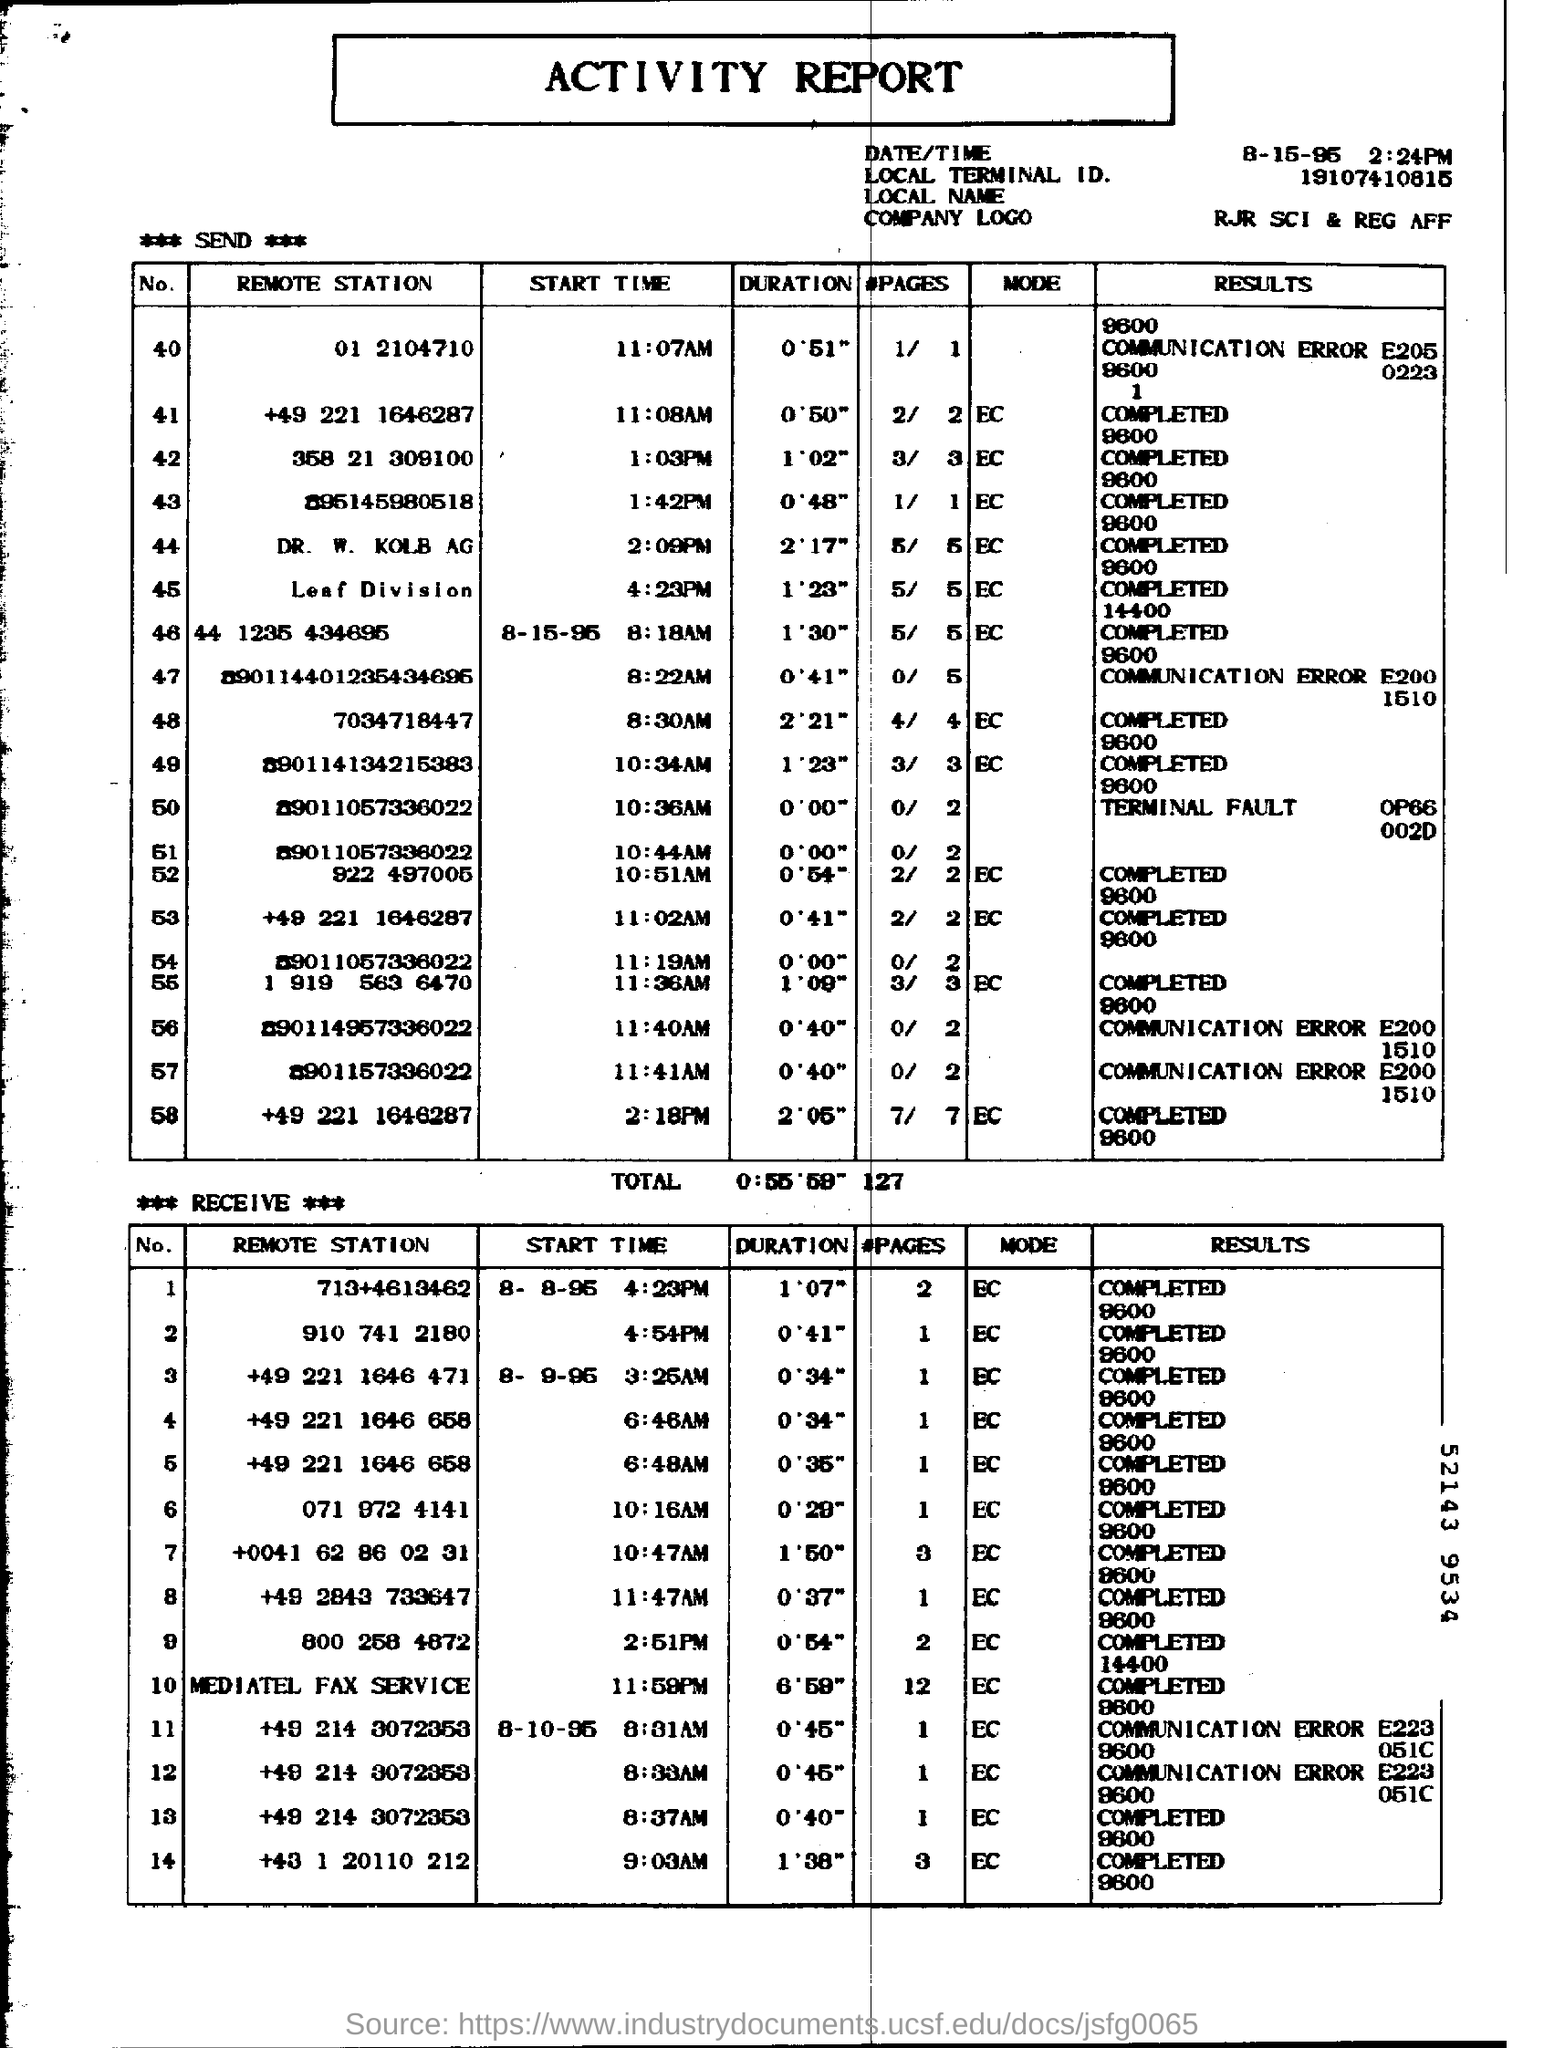What is the document title?
Offer a very short reply. ACTIVITY REPORT. What is the remote station No. 40?
Ensure brevity in your answer.  01  2104710. 